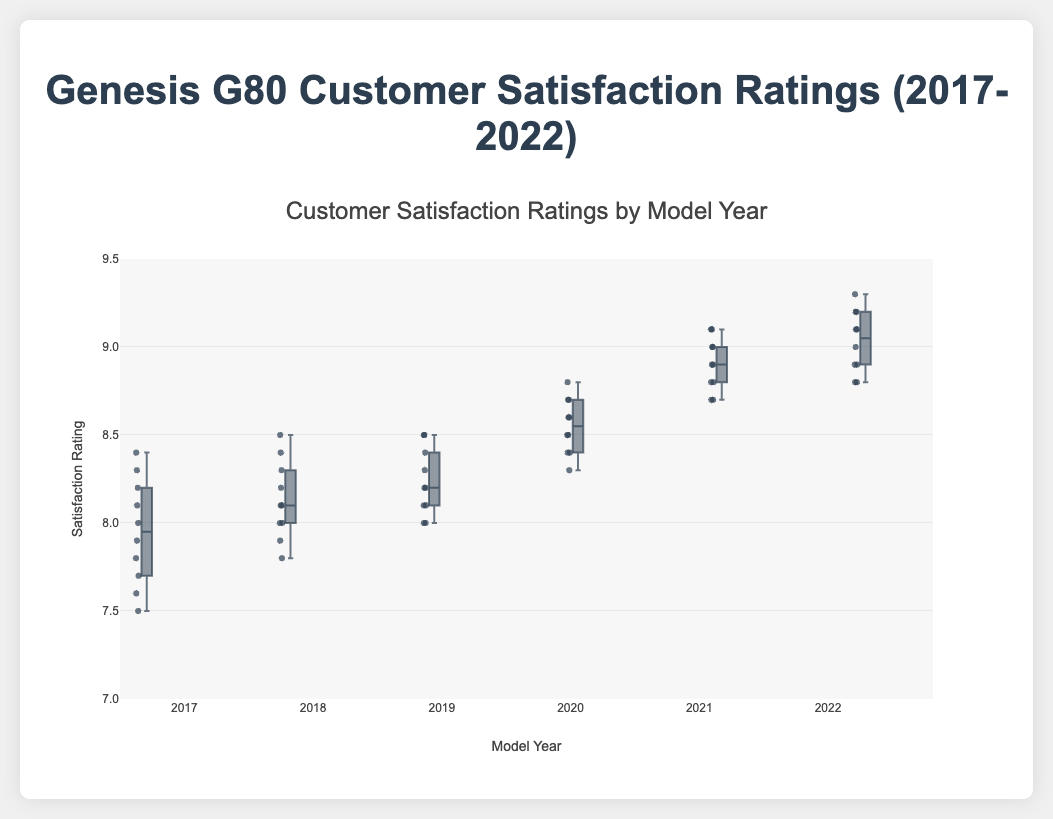What is the title of the box plot? The title is displayed at the top of the figure and is used to describe the content of the plot. Here, the title is given on the top of the plot.
Answer: Genesis G80 Customer Satisfaction Ratings (2017-2022) Which model year has the highest median customer satisfaction rating? To find the highest median, locate the middle line of the boxes. The year with the highest median is the one where this line is positioned at the highest rating value.
Answer: 2022 In which year did customer satisfaction ratings show the most variability? Variability is shown by the height difference between the upper and lower whiskers of the box. The taller the boxplot, including the whiskers, the higher the variability.
Answer: 2017 What is the lowest customer satisfaction rating in 2017? The lowest value is indicated by the bottom whisker of the 2017 box plot.
Answer: 7.5 How do the median satisfaction ratings compare between 2018 and 2020? Compare the middle line of the boxes (the medians) for 2018 and 2020. The median for 2020 is higher than that for 2018.
Answer: 2020 > 2018 Which model year has the smallest interquartile range (IQR)? The IQR is represented by the height of the box (from the lower to the upper quartile). The smallest box vertically reflects the smallest IQR.
Answer: 2022 What is the general trend of customer satisfaction ratings from 2017 to 2022? By observing the median lines from 2017 to 2022, one can see that the median customer satisfaction ratings generally increase from year to year.
Answer: Increasing For the year 2021, identify the range between the lowest and highest customer satisfaction ratings. The range is indicated by the difference between the top and bottom whiskers for the year 2021. The lowest is 8.7 and the highest is 9.1.
Answer: 0.4 Are there any outliers in the customer satisfaction ratings for the year 2019? Outliers are shown as individual points outside the whiskers of the box plots. For 2019, there are no points outside the whiskers.
Answer: No 